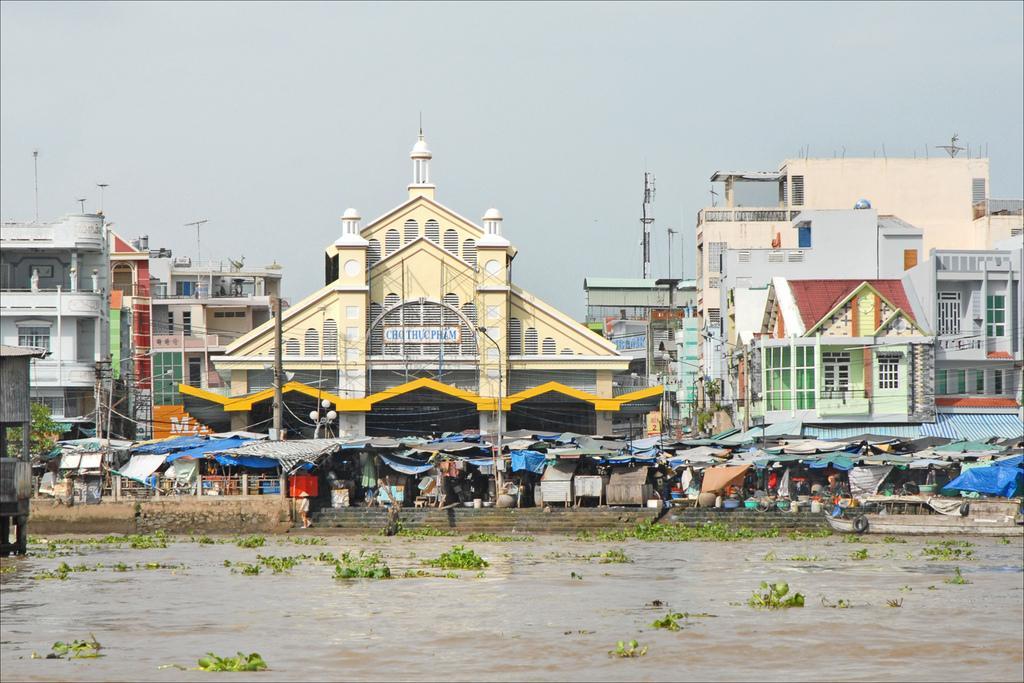How would you summarize this image in a sentence or two? In this picture we can see water at the bottom, in the background there are some buildings, we can see some sheds, poles, lights and stairs in the middle, we can see some leaves in the water, there is the sky at the top of the picture. 